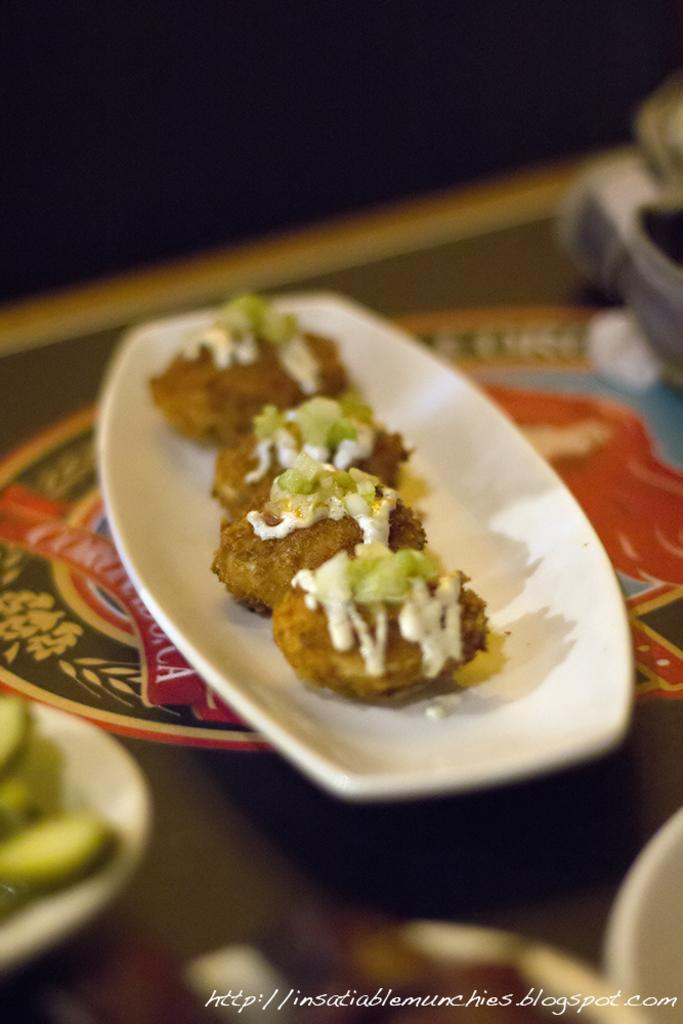What can be seen on the plates in the image? There are food items on the plates in the image. What else is present in the image besides the plates with food? There are other objects present in the image. Where are these objects placed? These objects are placed on a platform. What can be observed about the background of the image? The background of the image is dark. What type of wheel can be seen in the image? There is no wheel present in the image. Is the image set in space? The image does not depict a space setting; it is focused on plates with food items and other objects on a platform. 